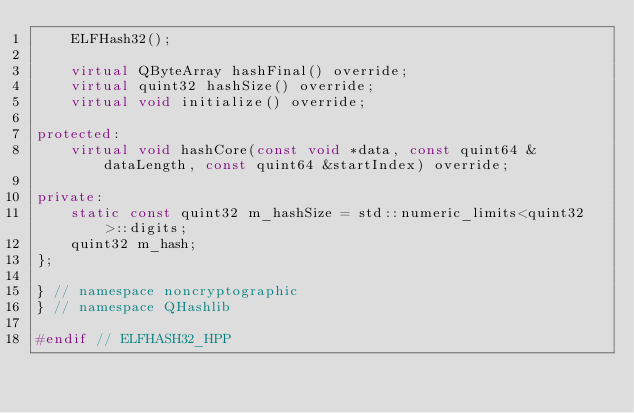Convert code to text. <code><loc_0><loc_0><loc_500><loc_500><_C++_>    ELFHash32();

    virtual QByteArray hashFinal() override;
    virtual quint32 hashSize() override;
    virtual void initialize() override;

protected:
    virtual void hashCore(const void *data, const quint64 &dataLength, const quint64 &startIndex) override;

private:
    static const quint32 m_hashSize = std::numeric_limits<quint32>::digits;
    quint32 m_hash;
};

} // namespace noncryptographic
} // namespace QHashlib

#endif // ELFHASH32_HPP
</code> 